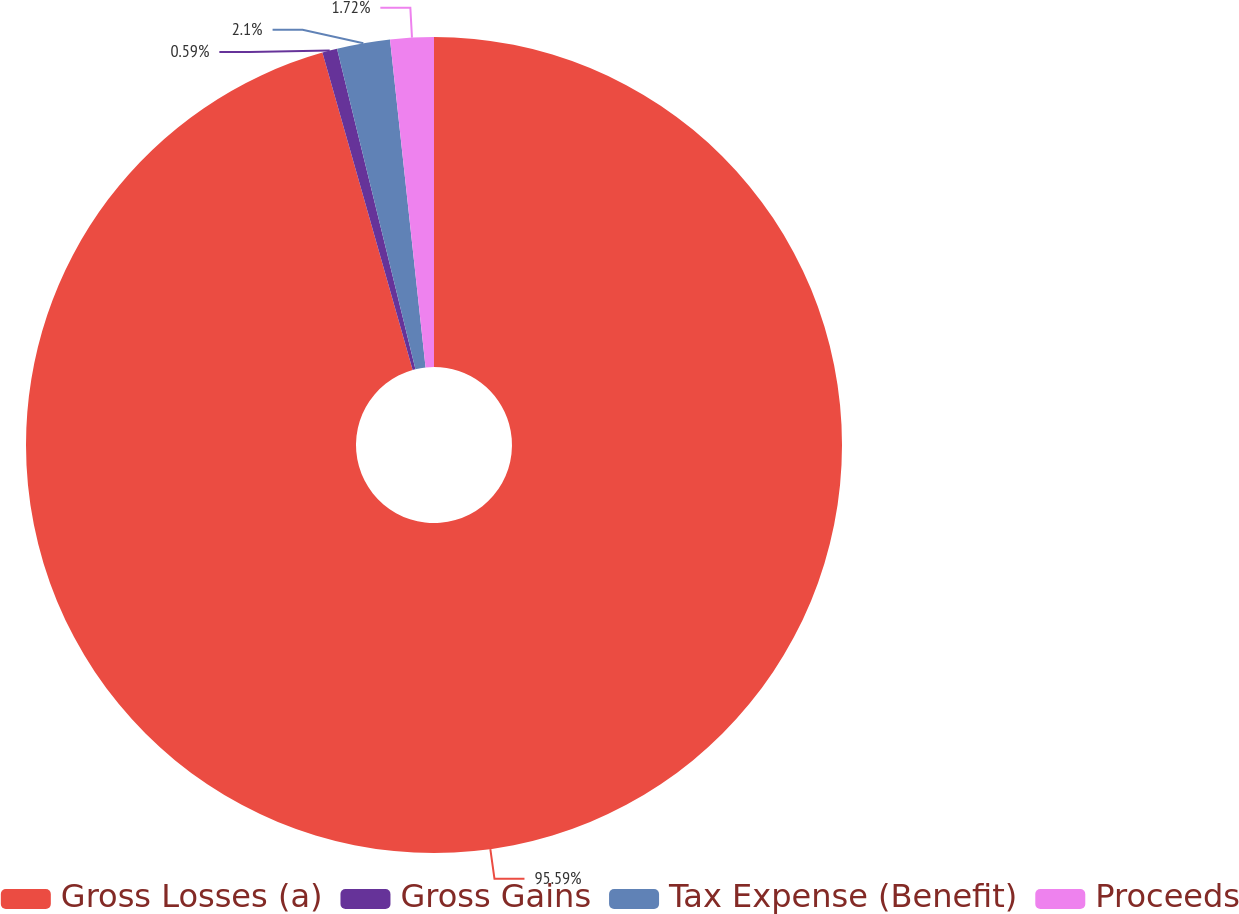<chart> <loc_0><loc_0><loc_500><loc_500><pie_chart><fcel>Gross Losses (a)<fcel>Gross Gains<fcel>Tax Expense (Benefit)<fcel>Proceeds<nl><fcel>95.6%<fcel>0.59%<fcel>2.1%<fcel>1.72%<nl></chart> 